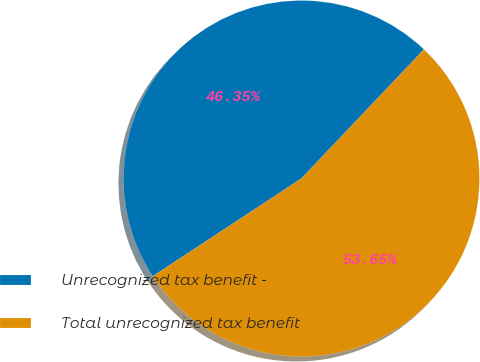<chart> <loc_0><loc_0><loc_500><loc_500><pie_chart><fcel>Unrecognized tax benefit -<fcel>Total unrecognized tax benefit<nl><fcel>46.35%<fcel>53.65%<nl></chart> 